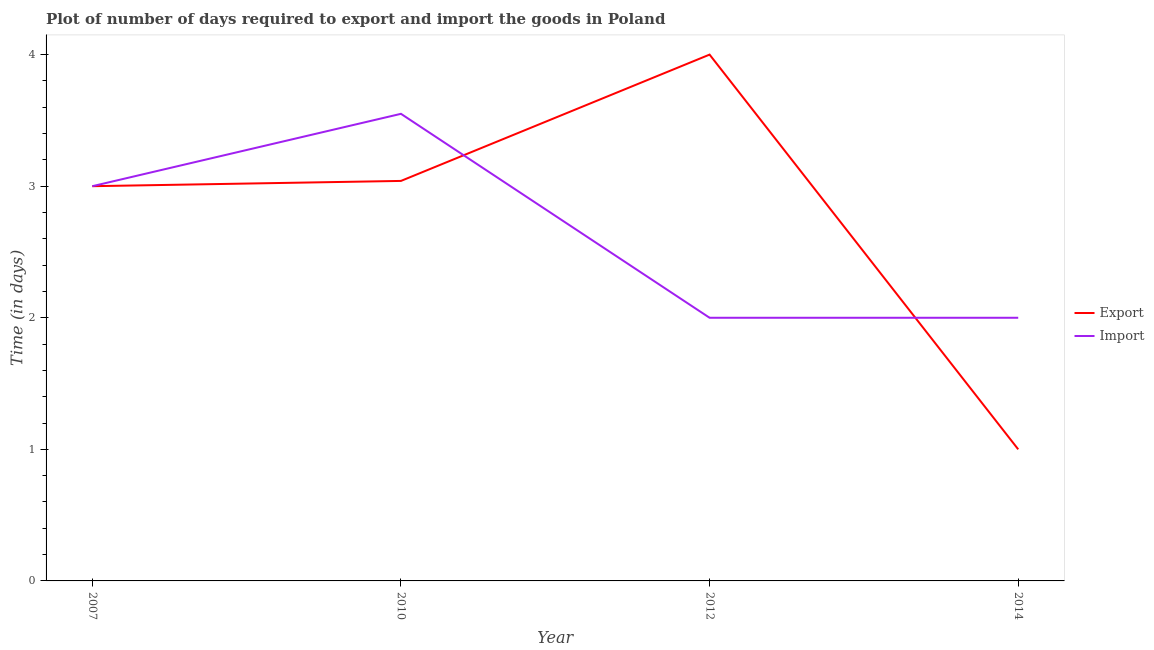Does the line corresponding to time required to import intersect with the line corresponding to time required to export?
Your answer should be compact. Yes. Across all years, what is the maximum time required to import?
Keep it short and to the point. 3.55. Across all years, what is the minimum time required to export?
Your answer should be compact. 1. What is the total time required to export in the graph?
Ensure brevity in your answer.  11.04. What is the difference between the time required to import in 2007 and that in 2014?
Provide a short and direct response. 1. What is the difference between the time required to import in 2014 and the time required to export in 2010?
Offer a terse response. -1.04. What is the average time required to export per year?
Provide a succinct answer. 2.76. What is the ratio of the time required to import in 2010 to that in 2014?
Ensure brevity in your answer.  1.77. Is the time required to export in 2007 less than that in 2012?
Make the answer very short. Yes. Is the difference between the time required to export in 2007 and 2010 greater than the difference between the time required to import in 2007 and 2010?
Your answer should be compact. Yes. What is the difference between the highest and the lowest time required to import?
Your answer should be compact. 1.55. In how many years, is the time required to import greater than the average time required to import taken over all years?
Give a very brief answer. 2. Does the time required to export monotonically increase over the years?
Offer a terse response. No. How many lines are there?
Offer a terse response. 2. What is the difference between two consecutive major ticks on the Y-axis?
Give a very brief answer. 1. Does the graph contain grids?
Offer a very short reply. No. How many legend labels are there?
Give a very brief answer. 2. How are the legend labels stacked?
Offer a terse response. Vertical. What is the title of the graph?
Offer a terse response. Plot of number of days required to export and import the goods in Poland. What is the label or title of the X-axis?
Your answer should be compact. Year. What is the label or title of the Y-axis?
Ensure brevity in your answer.  Time (in days). What is the Time (in days) of Import in 2007?
Give a very brief answer. 3. What is the Time (in days) of Export in 2010?
Ensure brevity in your answer.  3.04. What is the Time (in days) of Import in 2010?
Your answer should be compact. 3.55. What is the Time (in days) in Export in 2012?
Your answer should be compact. 4. What is the Time (in days) of Import in 2012?
Offer a very short reply. 2. Across all years, what is the maximum Time (in days) of Import?
Offer a very short reply. 3.55. What is the total Time (in days) in Export in the graph?
Give a very brief answer. 11.04. What is the total Time (in days) in Import in the graph?
Your answer should be very brief. 10.55. What is the difference between the Time (in days) of Export in 2007 and that in 2010?
Provide a succinct answer. -0.04. What is the difference between the Time (in days) in Import in 2007 and that in 2010?
Ensure brevity in your answer.  -0.55. What is the difference between the Time (in days) in Export in 2007 and that in 2014?
Your answer should be very brief. 2. What is the difference between the Time (in days) of Import in 2007 and that in 2014?
Your answer should be compact. 1. What is the difference between the Time (in days) in Export in 2010 and that in 2012?
Provide a succinct answer. -0.96. What is the difference between the Time (in days) in Import in 2010 and that in 2012?
Your answer should be compact. 1.55. What is the difference between the Time (in days) of Export in 2010 and that in 2014?
Your response must be concise. 2.04. What is the difference between the Time (in days) in Import in 2010 and that in 2014?
Give a very brief answer. 1.55. What is the difference between the Time (in days) in Export in 2012 and that in 2014?
Your answer should be compact. 3. What is the difference between the Time (in days) of Import in 2012 and that in 2014?
Offer a very short reply. 0. What is the difference between the Time (in days) of Export in 2007 and the Time (in days) of Import in 2010?
Keep it short and to the point. -0.55. What is the difference between the Time (in days) of Export in 2010 and the Time (in days) of Import in 2012?
Give a very brief answer. 1.04. What is the difference between the Time (in days) of Export in 2010 and the Time (in days) of Import in 2014?
Your answer should be very brief. 1.04. What is the difference between the Time (in days) in Export in 2012 and the Time (in days) in Import in 2014?
Your answer should be very brief. 2. What is the average Time (in days) of Export per year?
Provide a short and direct response. 2.76. What is the average Time (in days) of Import per year?
Your response must be concise. 2.64. In the year 2010, what is the difference between the Time (in days) in Export and Time (in days) in Import?
Offer a terse response. -0.51. In the year 2014, what is the difference between the Time (in days) of Export and Time (in days) of Import?
Give a very brief answer. -1. What is the ratio of the Time (in days) in Export in 2007 to that in 2010?
Make the answer very short. 0.99. What is the ratio of the Time (in days) in Import in 2007 to that in 2010?
Give a very brief answer. 0.85. What is the ratio of the Time (in days) in Export in 2007 to that in 2012?
Offer a very short reply. 0.75. What is the ratio of the Time (in days) of Import in 2007 to that in 2012?
Provide a short and direct response. 1.5. What is the ratio of the Time (in days) of Export in 2007 to that in 2014?
Your answer should be compact. 3. What is the ratio of the Time (in days) of Import in 2007 to that in 2014?
Provide a short and direct response. 1.5. What is the ratio of the Time (in days) of Export in 2010 to that in 2012?
Your answer should be very brief. 0.76. What is the ratio of the Time (in days) of Import in 2010 to that in 2012?
Your answer should be very brief. 1.77. What is the ratio of the Time (in days) in Export in 2010 to that in 2014?
Provide a short and direct response. 3.04. What is the ratio of the Time (in days) of Import in 2010 to that in 2014?
Your answer should be very brief. 1.77. What is the difference between the highest and the second highest Time (in days) in Import?
Ensure brevity in your answer.  0.55. What is the difference between the highest and the lowest Time (in days) of Import?
Provide a succinct answer. 1.55. 